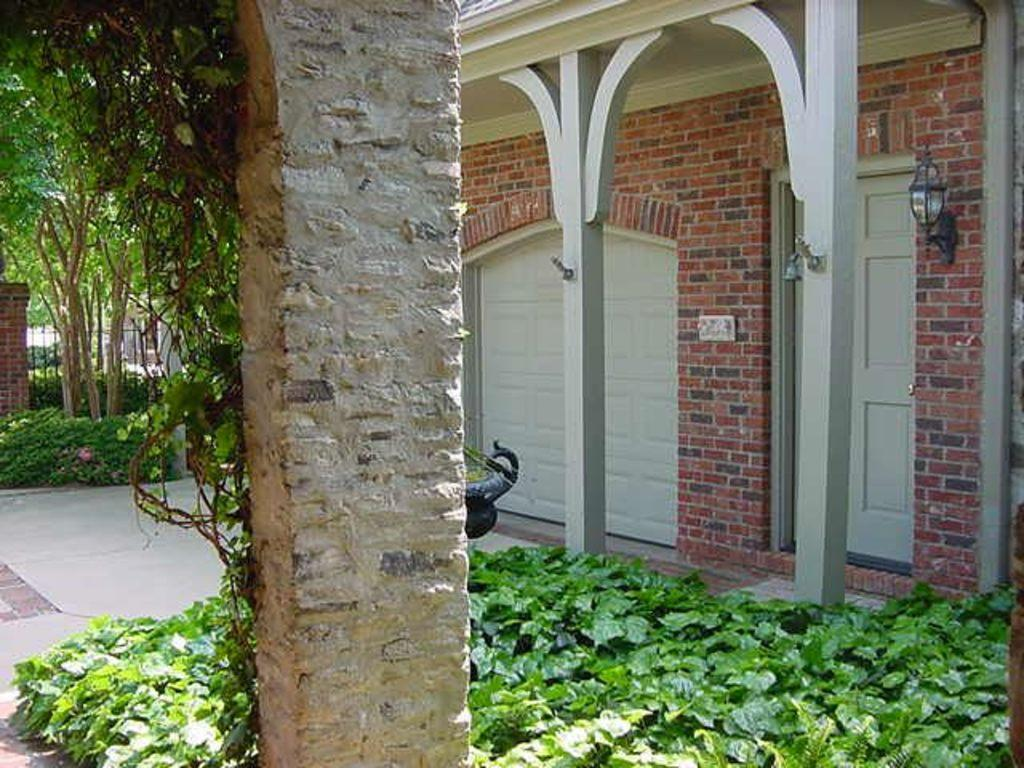What is the main structure in the center of the image? There is a pillar in the center of the image. What type of vegetation can be seen at the bottom of the image? Leaves are visible at the bottom of the image. What can be seen in the distance in the image? There are buildings, plants, a gate, and trees visible in the background of the image. What type of meal is being prepared in the image? There is no meal preparation visible in the image. Can you hear the drum being played in the image? There is no drum or sound present in the image. 